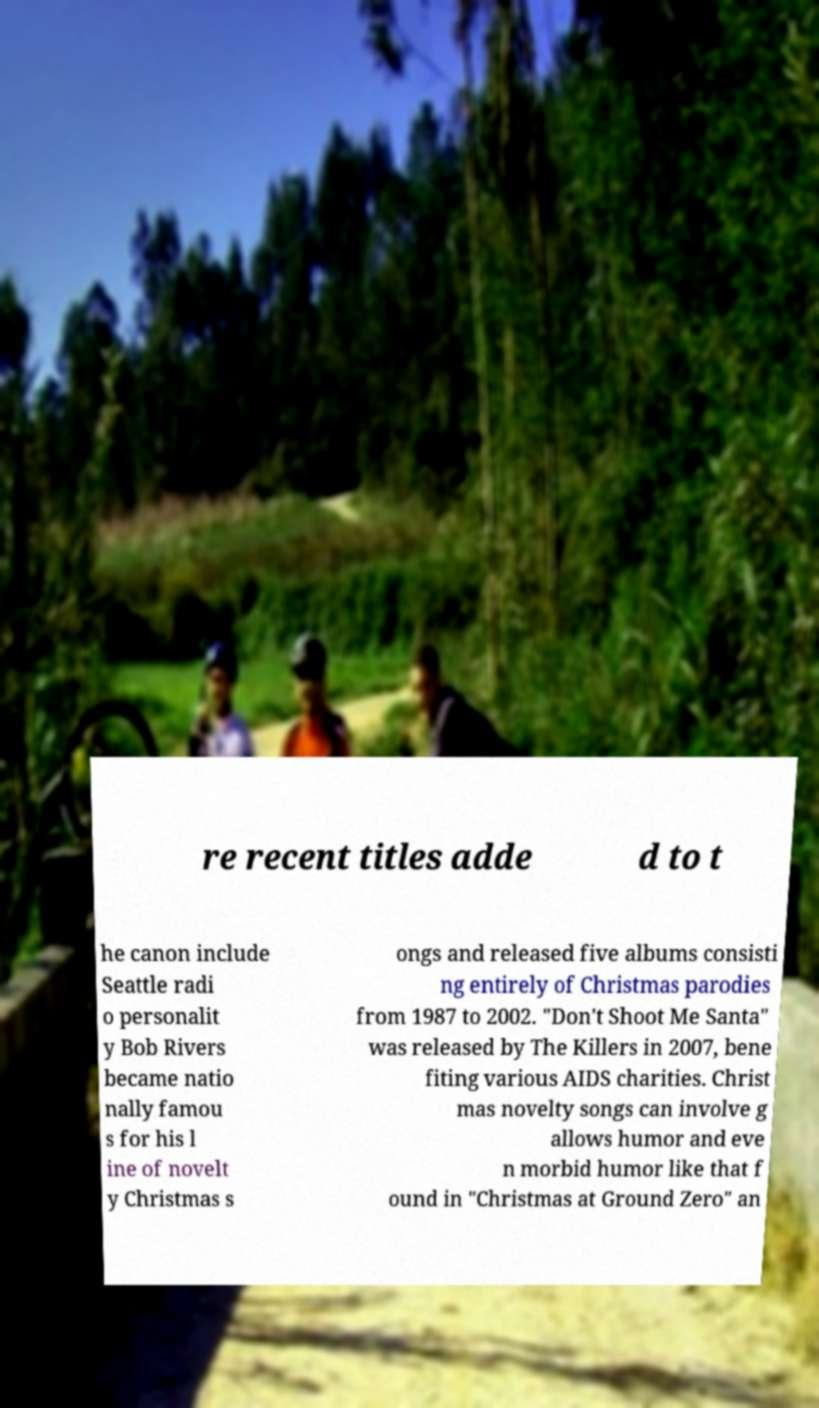Could you extract and type out the text from this image? re recent titles adde d to t he canon include Seattle radi o personalit y Bob Rivers became natio nally famou s for his l ine of novelt y Christmas s ongs and released five albums consisti ng entirely of Christmas parodies from 1987 to 2002. "Don't Shoot Me Santa" was released by The Killers in 2007, bene fiting various AIDS charities. Christ mas novelty songs can involve g allows humor and eve n morbid humor like that f ound in "Christmas at Ground Zero" an 